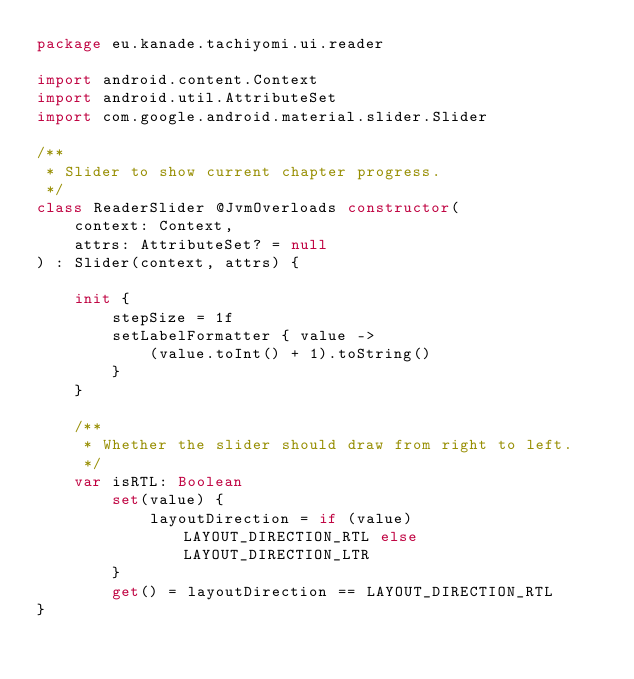Convert code to text. <code><loc_0><loc_0><loc_500><loc_500><_Kotlin_>package eu.kanade.tachiyomi.ui.reader

import android.content.Context
import android.util.AttributeSet
import com.google.android.material.slider.Slider

/**
 * Slider to show current chapter progress.
 */
class ReaderSlider @JvmOverloads constructor(
    context: Context,
    attrs: AttributeSet? = null
) : Slider(context, attrs) {

    init {
        stepSize = 1f
        setLabelFormatter { value ->
            (value.toInt() + 1).toString()
        }
    }

    /**
     * Whether the slider should draw from right to left.
     */
    var isRTL: Boolean
        set(value) {
            layoutDirection = if (value) LAYOUT_DIRECTION_RTL else LAYOUT_DIRECTION_LTR
        }
        get() = layoutDirection == LAYOUT_DIRECTION_RTL
}
</code> 